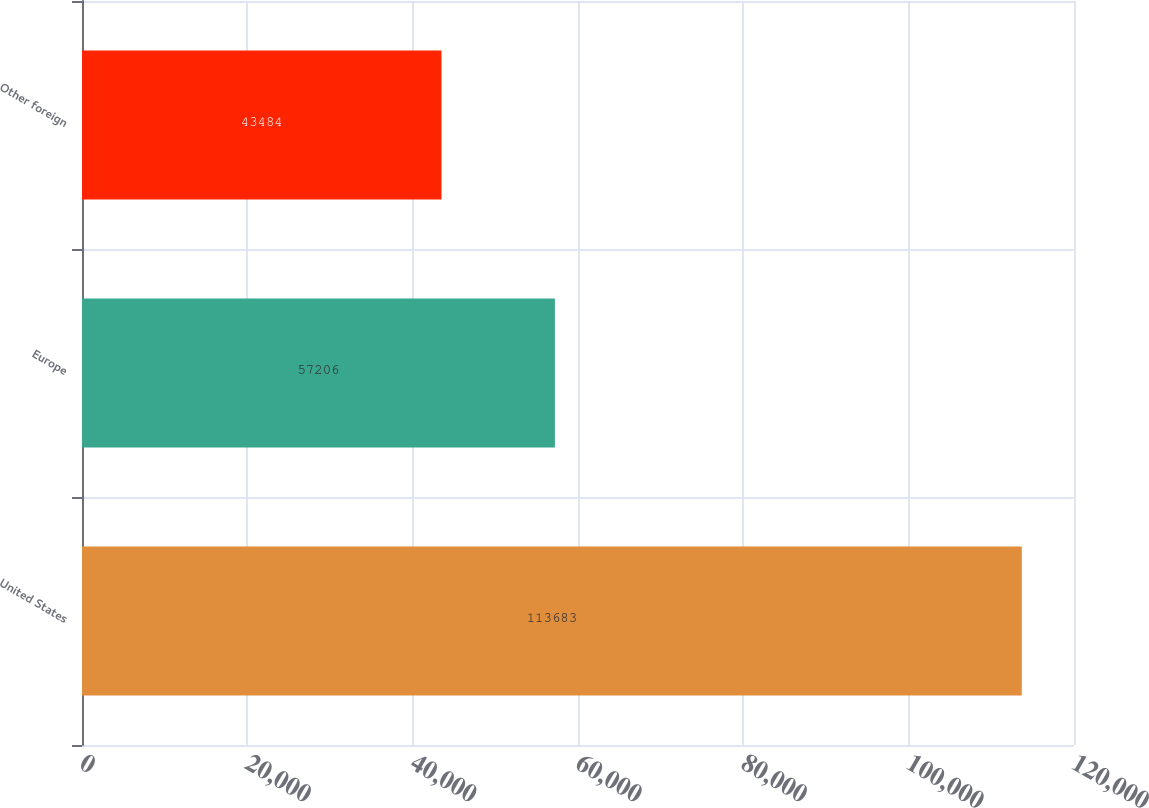Convert chart to OTSL. <chart><loc_0><loc_0><loc_500><loc_500><bar_chart><fcel>United States<fcel>Europe<fcel>Other foreign<nl><fcel>113683<fcel>57206<fcel>43484<nl></chart> 